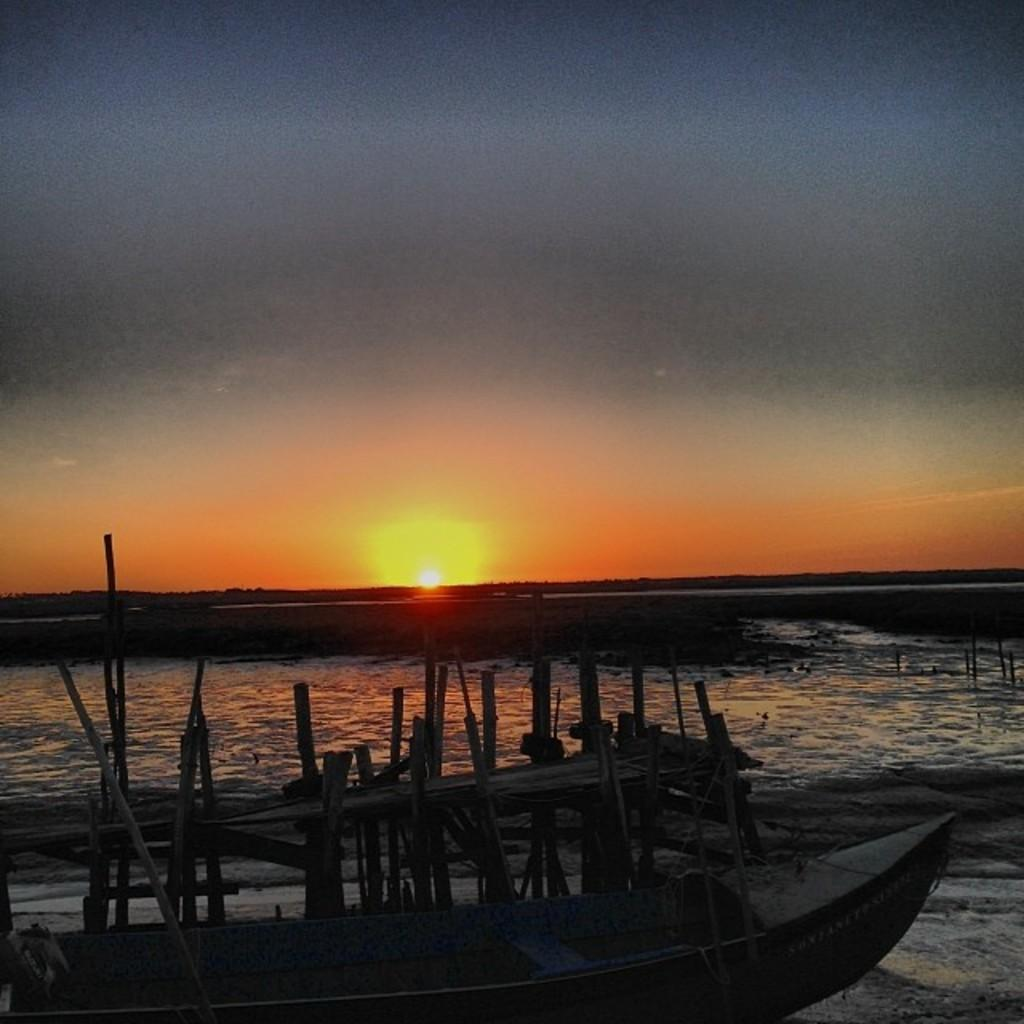What is at the bottom of the image? There is water at the bottom of the image. What can be seen in the front of the image? There is a boat in the front of the image. What is visible in the background of the image? The Sun and the sky are visible in the background of the image. What type of grain is being harvested in the image? There is no grain present in the image; it features water, a boat, the Sun, and the sky. What emotion is being expressed by the boat in the image? The boat is an inanimate object and cannot express emotions like regret or harmony. 